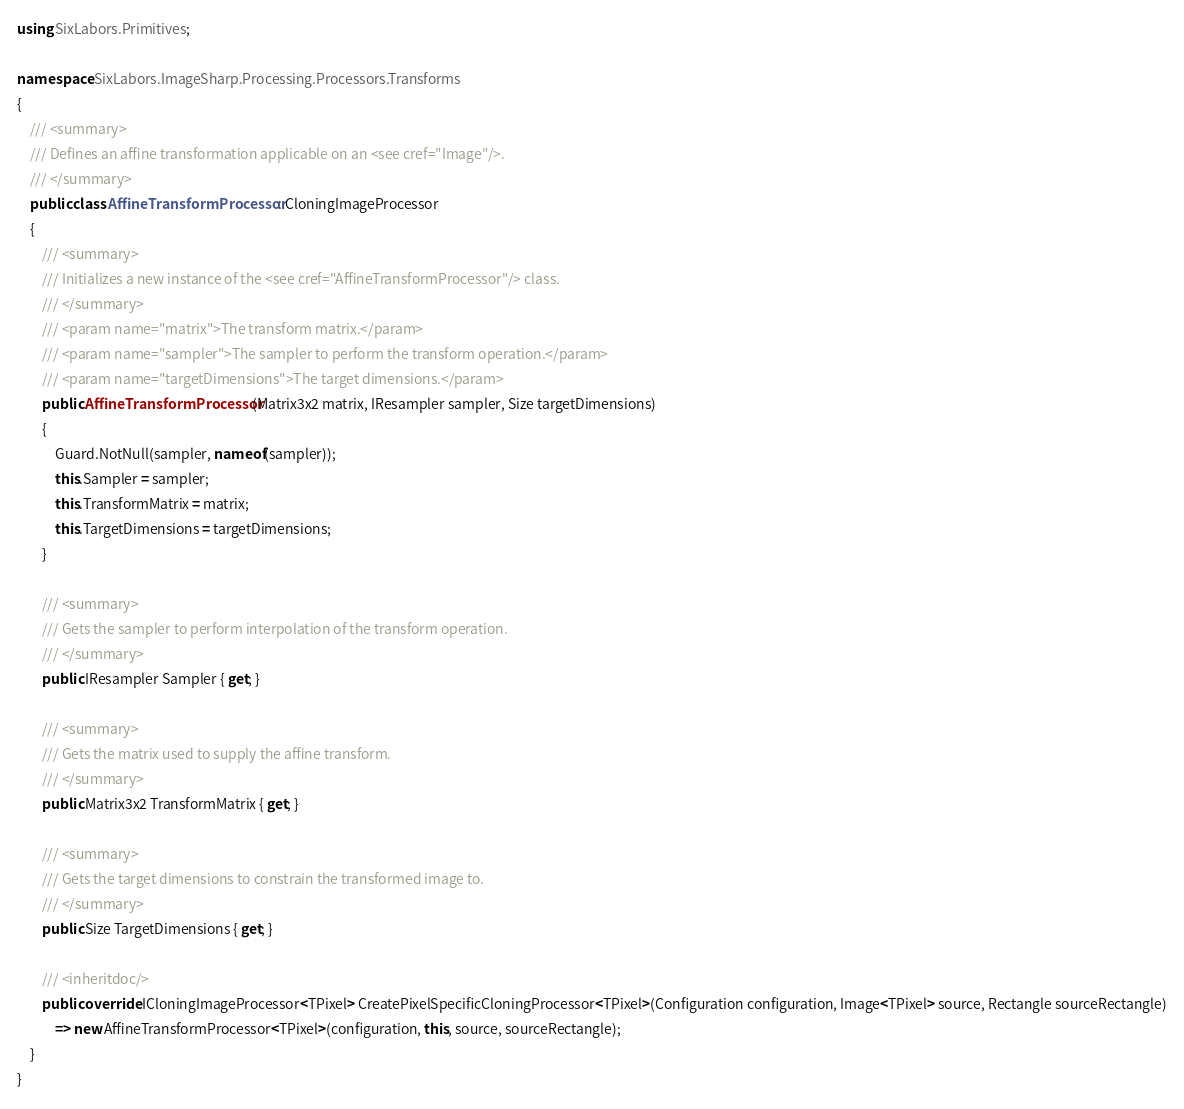<code> <loc_0><loc_0><loc_500><loc_500><_C#_>using SixLabors.Primitives;

namespace SixLabors.ImageSharp.Processing.Processors.Transforms
{
    /// <summary>
    /// Defines an affine transformation applicable on an <see cref="Image"/>.
    /// </summary>
    public class AffineTransformProcessor : CloningImageProcessor
    {
        /// <summary>
        /// Initializes a new instance of the <see cref="AffineTransformProcessor"/> class.
        /// </summary>
        /// <param name="matrix">The transform matrix.</param>
        /// <param name="sampler">The sampler to perform the transform operation.</param>
        /// <param name="targetDimensions">The target dimensions.</param>
        public AffineTransformProcessor(Matrix3x2 matrix, IResampler sampler, Size targetDimensions)
        {
            Guard.NotNull(sampler, nameof(sampler));
            this.Sampler = sampler;
            this.TransformMatrix = matrix;
            this.TargetDimensions = targetDimensions;
        }

        /// <summary>
        /// Gets the sampler to perform interpolation of the transform operation.
        /// </summary>
        public IResampler Sampler { get; }

        /// <summary>
        /// Gets the matrix used to supply the affine transform.
        /// </summary>
        public Matrix3x2 TransformMatrix { get; }

        /// <summary>
        /// Gets the target dimensions to constrain the transformed image to.
        /// </summary>
        public Size TargetDimensions { get; }

        /// <inheritdoc/>
        public override ICloningImageProcessor<TPixel> CreatePixelSpecificCloningProcessor<TPixel>(Configuration configuration, Image<TPixel> source, Rectangle sourceRectangle)
            => new AffineTransformProcessor<TPixel>(configuration, this, source, sourceRectangle);
    }
}
</code> 